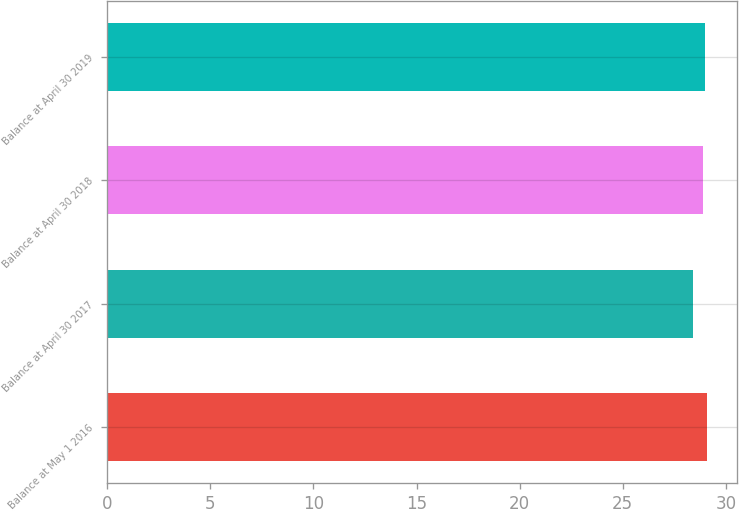Convert chart to OTSL. <chart><loc_0><loc_0><loc_500><loc_500><bar_chart><fcel>Balance at May 1 2016<fcel>Balance at April 30 2017<fcel>Balance at April 30 2018<fcel>Balance at April 30 2019<nl><fcel>29.1<fcel>28.4<fcel>28.9<fcel>28.97<nl></chart> 